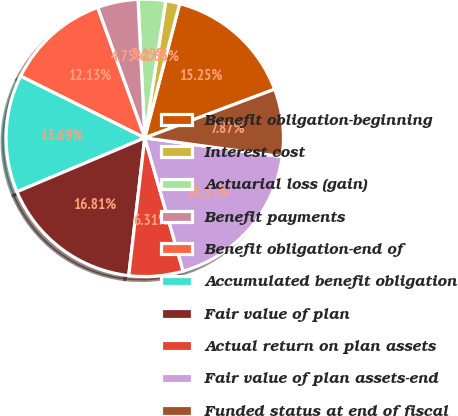<chart> <loc_0><loc_0><loc_500><loc_500><pie_chart><fcel>Benefit obligation-beginning<fcel>Interest cost<fcel>Actuarial loss (gain)<fcel>Benefit payments<fcel>Benefit obligation-end of<fcel>Accumulated benefit obligation<fcel>Fair value of plan<fcel>Actual return on plan assets<fcel>Fair value of plan assets-end<fcel>Funded status at end of fiscal<nl><fcel>15.25%<fcel>1.63%<fcel>3.19%<fcel>4.75%<fcel>12.13%<fcel>13.69%<fcel>16.81%<fcel>6.31%<fcel>18.37%<fcel>7.87%<nl></chart> 